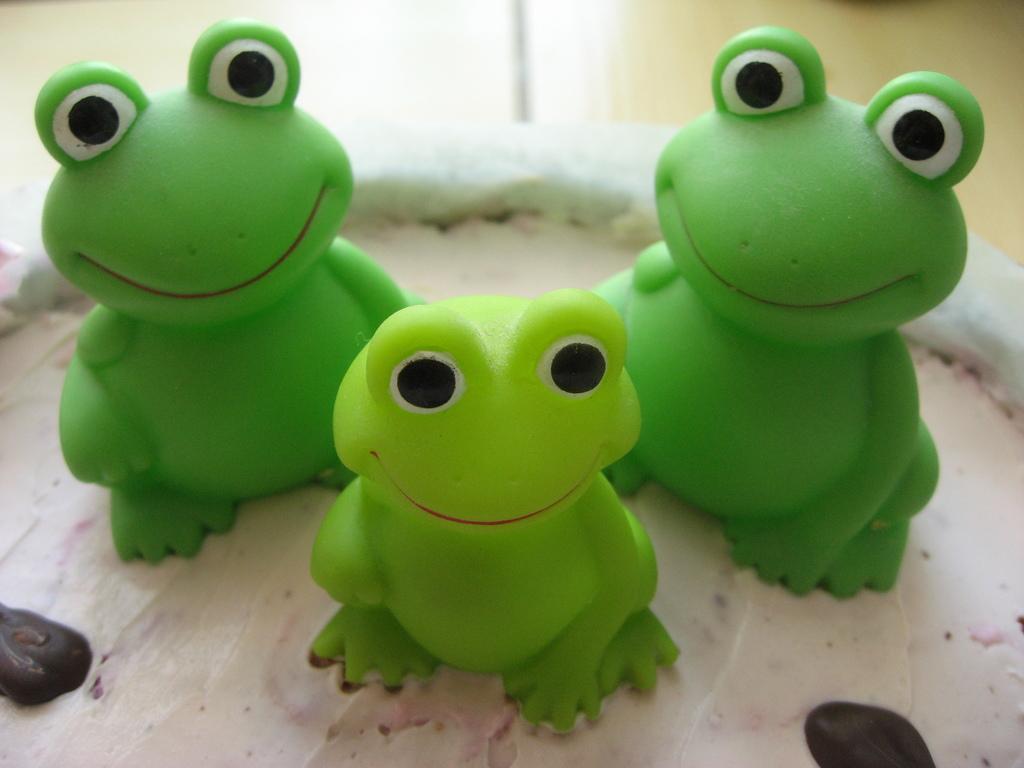How would you summarize this image in a sentence or two? In this image I can see the toys on the food item. These toys are in green color. And there is a blurred background. 